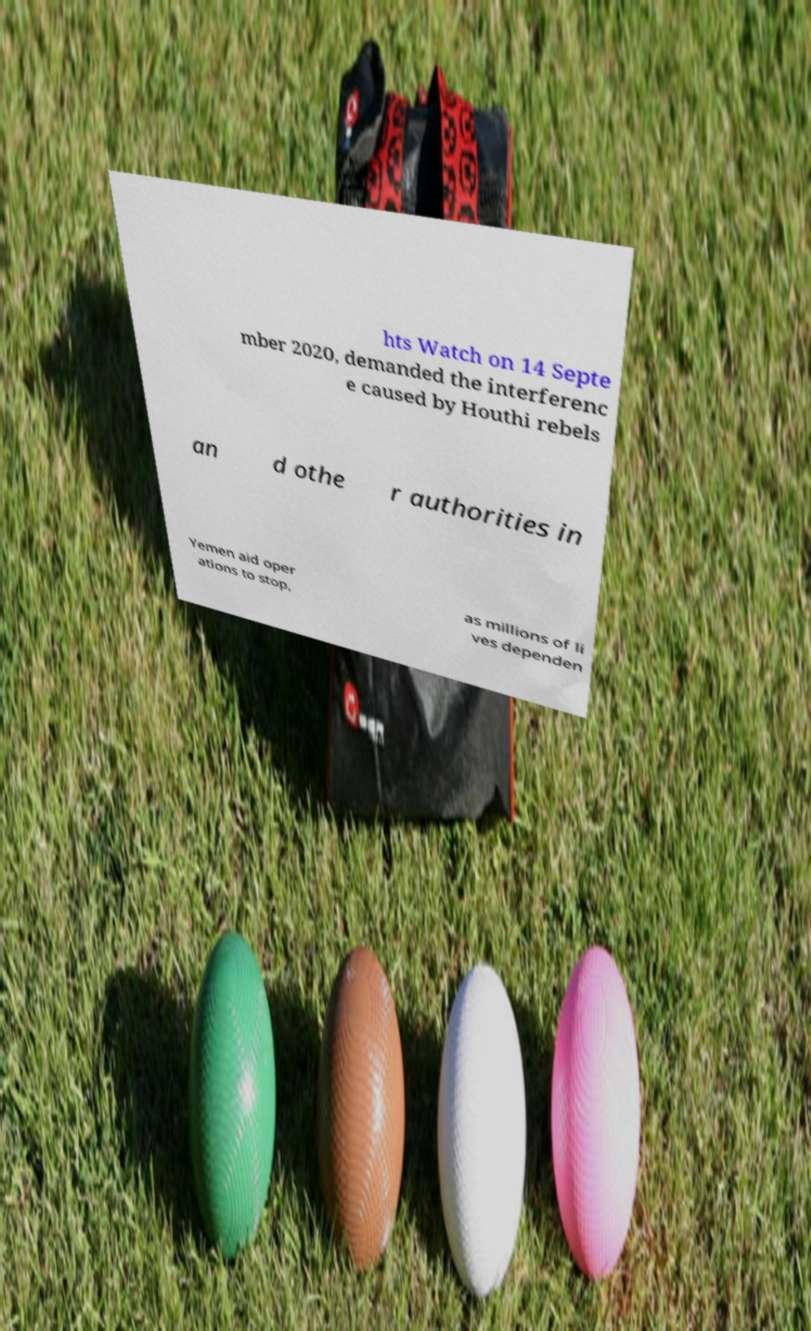Could you assist in decoding the text presented in this image and type it out clearly? hts Watch on 14 Septe mber 2020, demanded the interferenc e caused by Houthi rebels an d othe r authorities in Yemen aid oper ations to stop, as millions of li ves dependen 